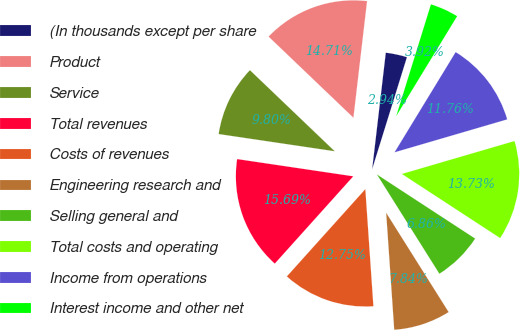<chart> <loc_0><loc_0><loc_500><loc_500><pie_chart><fcel>(In thousands except per share<fcel>Product<fcel>Service<fcel>Total revenues<fcel>Costs of revenues<fcel>Engineering research and<fcel>Selling general and<fcel>Total costs and operating<fcel>Income from operations<fcel>Interest income and other net<nl><fcel>2.94%<fcel>14.71%<fcel>9.8%<fcel>15.69%<fcel>12.75%<fcel>7.84%<fcel>6.86%<fcel>13.73%<fcel>11.76%<fcel>3.92%<nl></chart> 